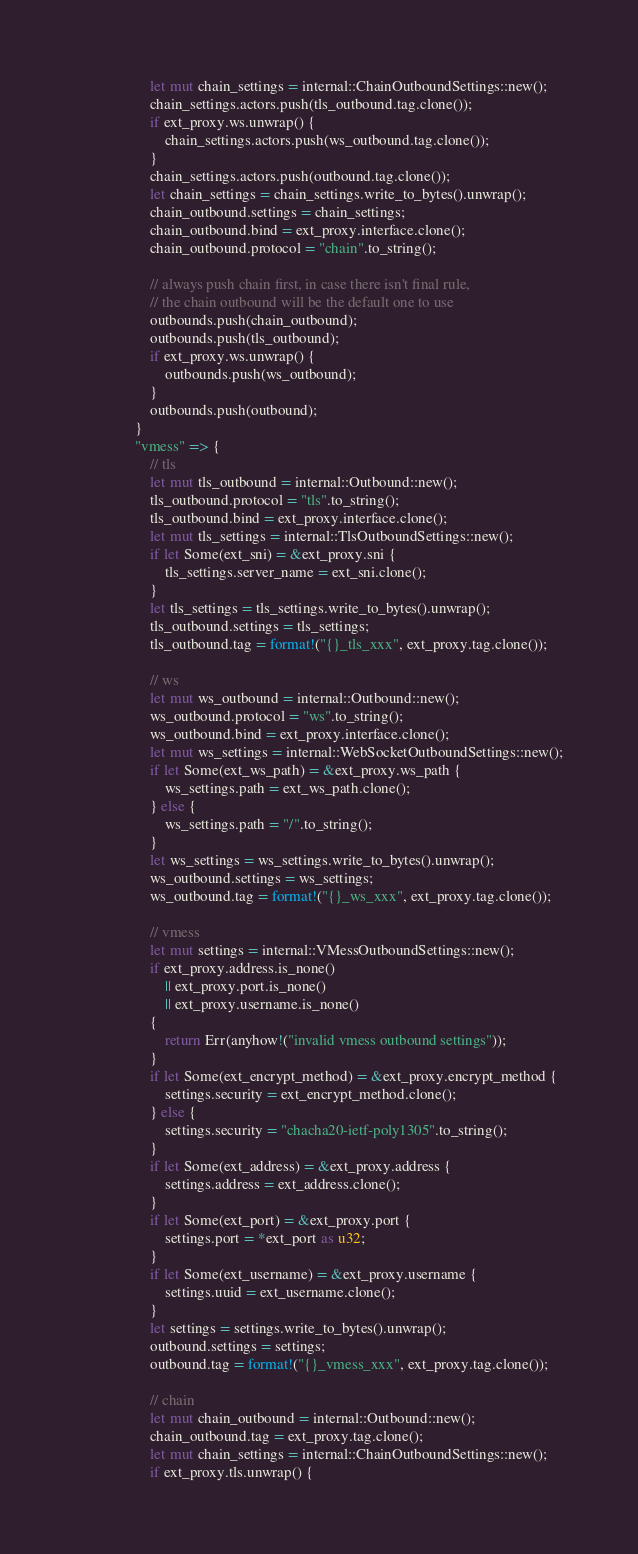<code> <loc_0><loc_0><loc_500><loc_500><_Rust_>                    let mut chain_settings = internal::ChainOutboundSettings::new();
                    chain_settings.actors.push(tls_outbound.tag.clone());
                    if ext_proxy.ws.unwrap() {
                        chain_settings.actors.push(ws_outbound.tag.clone());
                    }
                    chain_settings.actors.push(outbound.tag.clone());
                    let chain_settings = chain_settings.write_to_bytes().unwrap();
                    chain_outbound.settings = chain_settings;
                    chain_outbound.bind = ext_proxy.interface.clone();
                    chain_outbound.protocol = "chain".to_string();

                    // always push chain first, in case there isn't final rule,
                    // the chain outbound will be the default one to use
                    outbounds.push(chain_outbound);
                    outbounds.push(tls_outbound);
                    if ext_proxy.ws.unwrap() {
                        outbounds.push(ws_outbound);
                    }
                    outbounds.push(outbound);
                }
                "vmess" => {
                    // tls
                    let mut tls_outbound = internal::Outbound::new();
                    tls_outbound.protocol = "tls".to_string();
                    tls_outbound.bind = ext_proxy.interface.clone();
                    let mut tls_settings = internal::TlsOutboundSettings::new();
                    if let Some(ext_sni) = &ext_proxy.sni {
                        tls_settings.server_name = ext_sni.clone();
                    }
                    let tls_settings = tls_settings.write_to_bytes().unwrap();
                    tls_outbound.settings = tls_settings;
                    tls_outbound.tag = format!("{}_tls_xxx", ext_proxy.tag.clone());

                    // ws
                    let mut ws_outbound = internal::Outbound::new();
                    ws_outbound.protocol = "ws".to_string();
                    ws_outbound.bind = ext_proxy.interface.clone();
                    let mut ws_settings = internal::WebSocketOutboundSettings::new();
                    if let Some(ext_ws_path) = &ext_proxy.ws_path {
                        ws_settings.path = ext_ws_path.clone();
                    } else {
                        ws_settings.path = "/".to_string();
                    }
                    let ws_settings = ws_settings.write_to_bytes().unwrap();
                    ws_outbound.settings = ws_settings;
                    ws_outbound.tag = format!("{}_ws_xxx", ext_proxy.tag.clone());

                    // vmess
                    let mut settings = internal::VMessOutboundSettings::new();
                    if ext_proxy.address.is_none()
                        || ext_proxy.port.is_none()
                        || ext_proxy.username.is_none()
                    {
                        return Err(anyhow!("invalid vmess outbound settings"));
                    }
                    if let Some(ext_encrypt_method) = &ext_proxy.encrypt_method {
                        settings.security = ext_encrypt_method.clone();
                    } else {
                        settings.security = "chacha20-ietf-poly1305".to_string();
                    }
                    if let Some(ext_address) = &ext_proxy.address {
                        settings.address = ext_address.clone();
                    }
                    if let Some(ext_port) = &ext_proxy.port {
                        settings.port = *ext_port as u32;
                    }
                    if let Some(ext_username) = &ext_proxy.username {
                        settings.uuid = ext_username.clone();
                    }
                    let settings = settings.write_to_bytes().unwrap();
                    outbound.settings = settings;
                    outbound.tag = format!("{}_vmess_xxx", ext_proxy.tag.clone());

                    // chain
                    let mut chain_outbound = internal::Outbound::new();
                    chain_outbound.tag = ext_proxy.tag.clone();
                    let mut chain_settings = internal::ChainOutboundSettings::new();
                    if ext_proxy.tls.unwrap() {</code> 